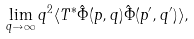Convert formula to latex. <formula><loc_0><loc_0><loc_500><loc_500>\lim _ { q \to \infty } q ^ { 2 } \langle T ^ { * } \hat { \Phi } ( p , q ) \hat { \Phi } ( p ^ { \prime } , q ^ { \prime } ) \rangle ,</formula> 